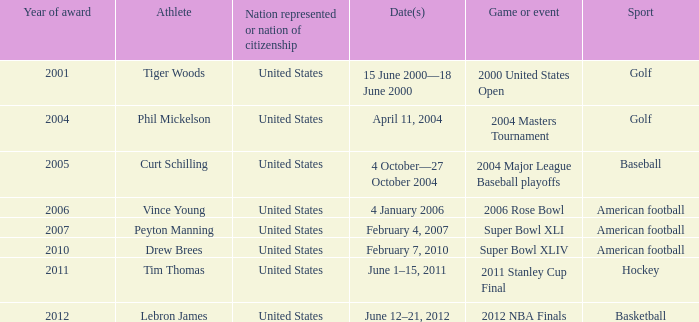Which sport was granted the year award in 2011? Hockey. Could you help me parse every detail presented in this table? {'header': ['Year of award', 'Athlete', 'Nation represented or nation of citizenship', 'Date(s)', 'Game or event', 'Sport'], 'rows': [['2001', 'Tiger Woods', 'United States', '15 June 2000—18 June 2000', '2000 United States Open', 'Golf'], ['2004', 'Phil Mickelson', 'United States', 'April 11, 2004', '2004 Masters Tournament', 'Golf'], ['2005', 'Curt Schilling', 'United States', '4 October—27 October 2004', '2004 Major League Baseball playoffs', 'Baseball'], ['2006', 'Vince Young', 'United States', '4 January 2006', '2006 Rose Bowl', 'American football'], ['2007', 'Peyton Manning', 'United States', 'February 4, 2007', 'Super Bowl XLI', 'American football'], ['2010', 'Drew Brees', 'United States', 'February 7, 2010', 'Super Bowl XLIV', 'American football'], ['2011', 'Tim Thomas', 'United States', 'June 1–15, 2011', '2011 Stanley Cup Final', 'Hockey'], ['2012', 'Lebron James', 'United States', 'June 12–21, 2012', '2012 NBA Finals', 'Basketball']]} 